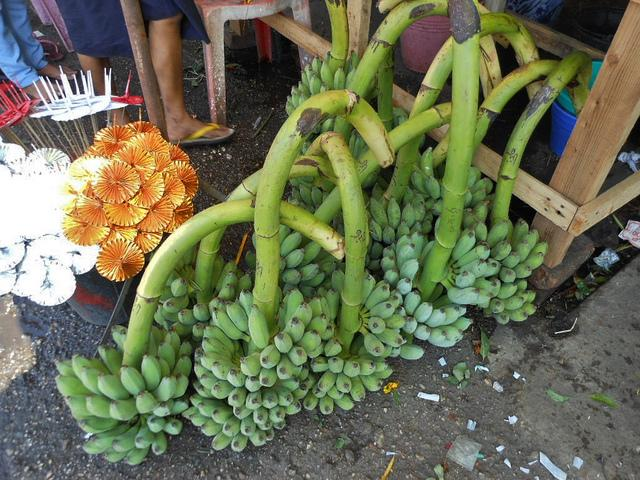What is the brown post behind the green fruit made of?

Choices:
A) sand
B) concrete
C) wood
D) plastic wood 